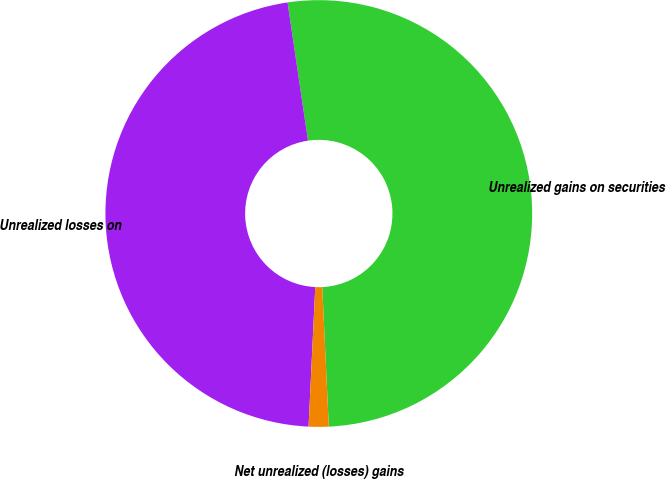Convert chart to OTSL. <chart><loc_0><loc_0><loc_500><loc_500><pie_chart><fcel>Unrealized gains on securities<fcel>Unrealized losses on<fcel>Net unrealized (losses) gains<nl><fcel>51.59%<fcel>46.9%<fcel>1.51%<nl></chart> 